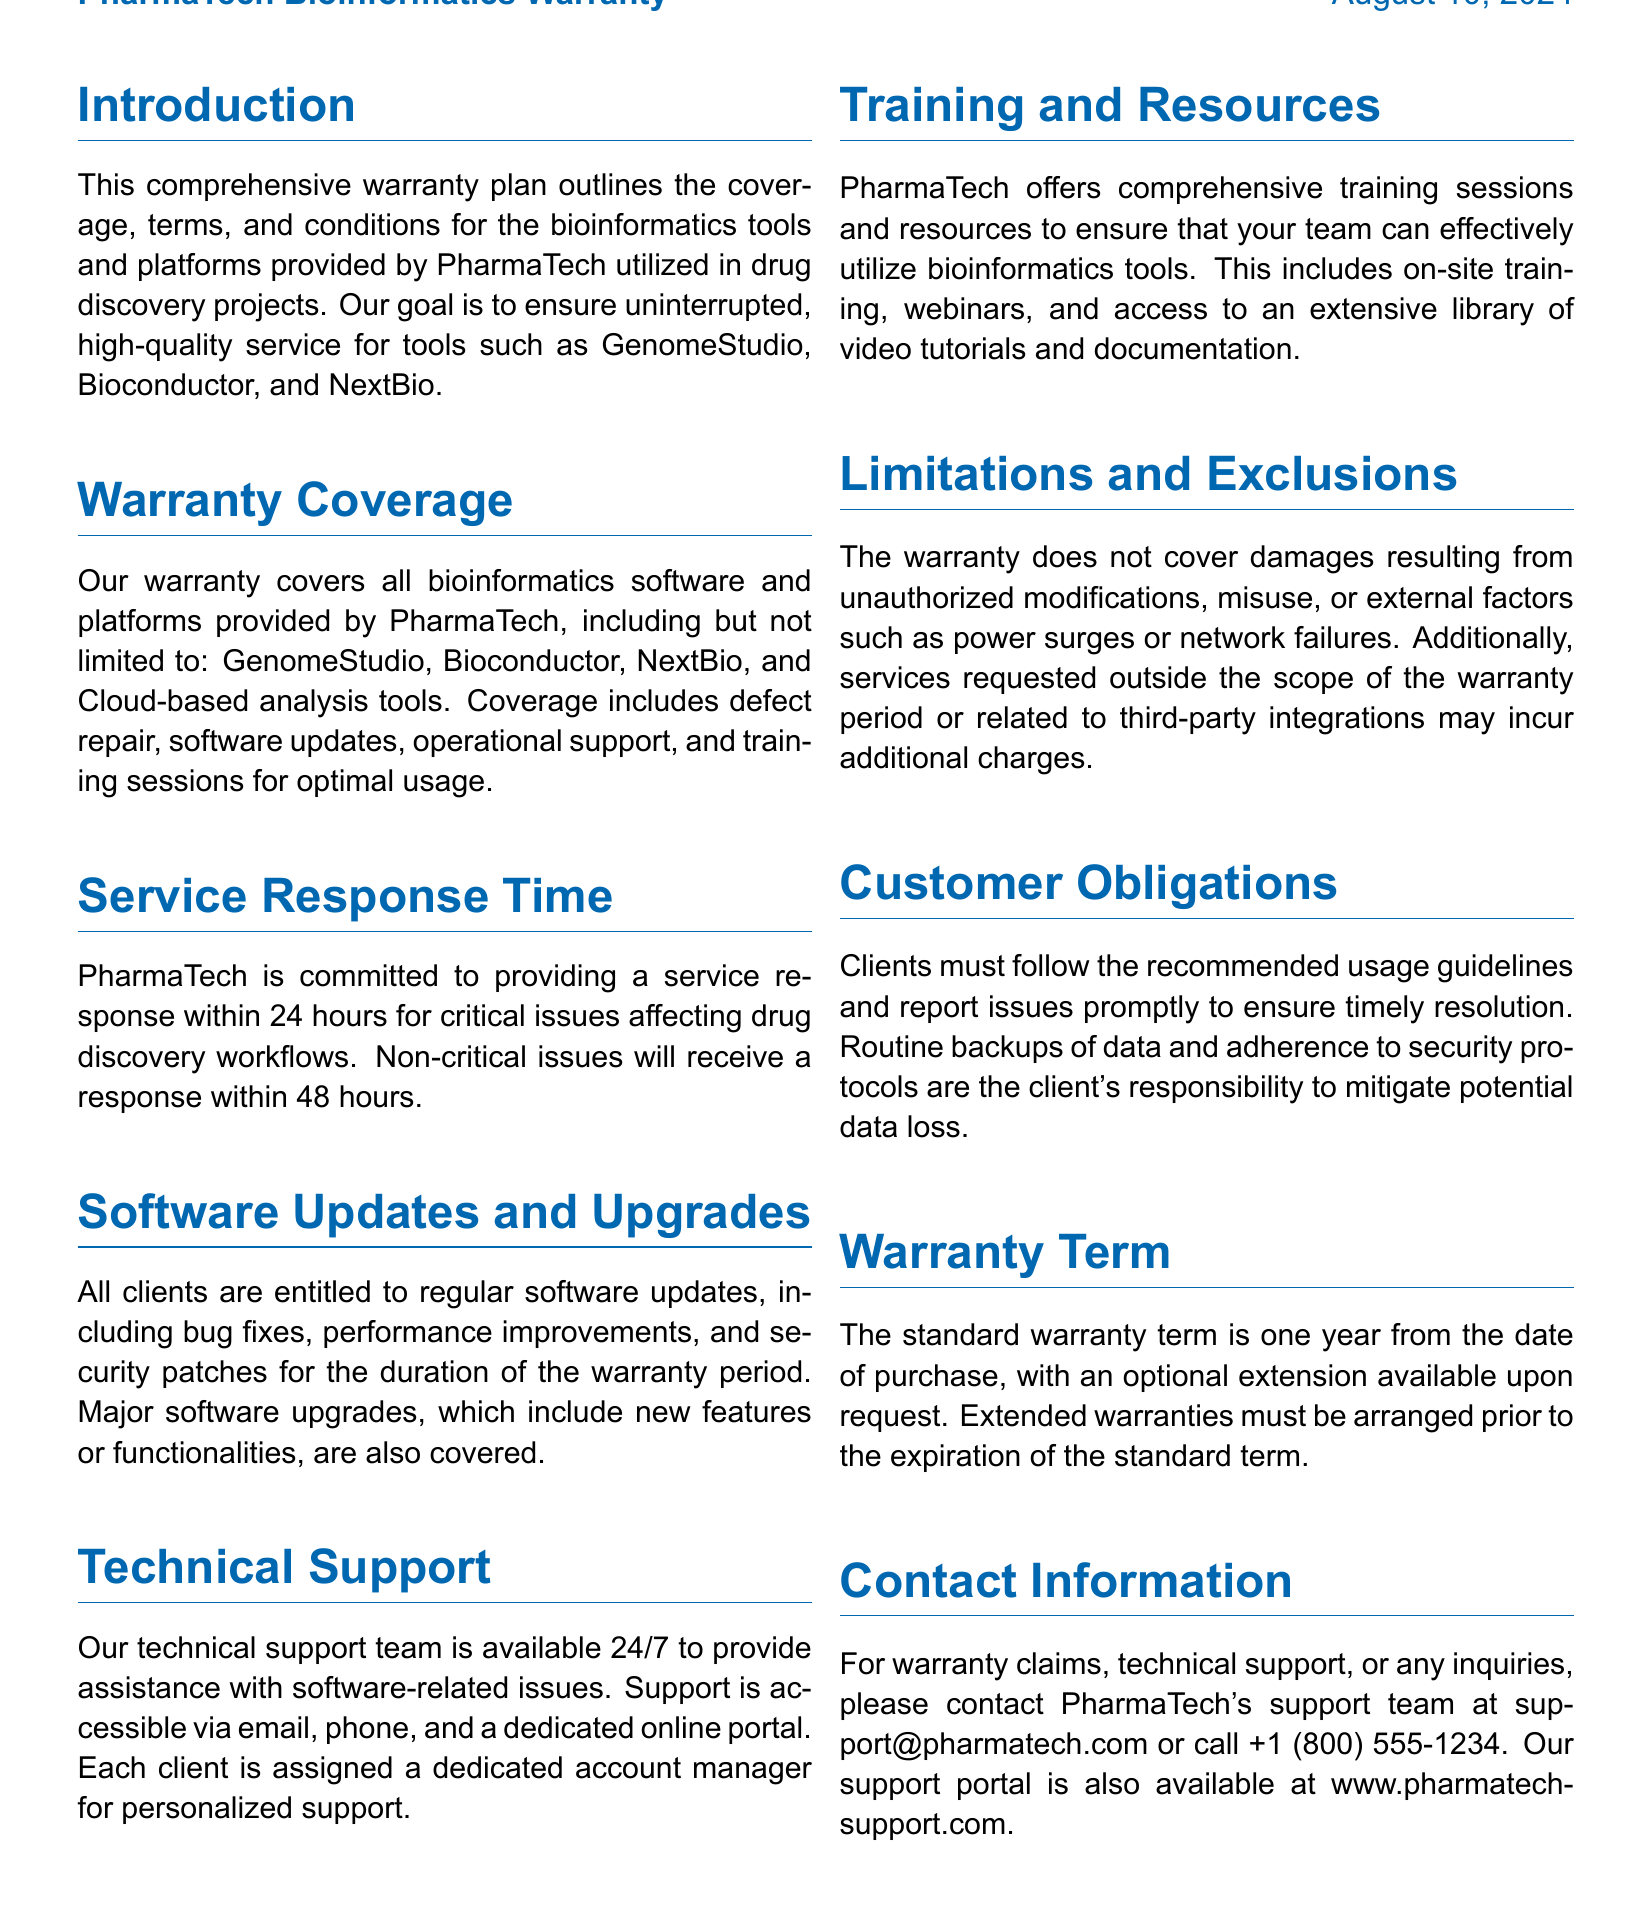What is the warranty term? The standard warranty term is specified in the document and is one year from the date of purchase.
Answer: one year What coverage does the warranty provide? The document lists specific areas covered by the warranty, including defect repair, software updates, and operational support.
Answer: defect repair, software updates, operational support How long is the service response for critical issues? The document states the commitment for service response times regarding critical issues affecting drug discovery workflows.
Answer: 24 hours Which platforms are included in the warranty? The document mentions specific bioinformatics software that falls under the warranty.
Answer: GenomeStudio, Bioconductor, NextBio, Cloud-based analysis tools What additional training resources are provided? The document outlines the types of training and resources offered to clients under the warranty.
Answer: on-site training, webinars, video tutorials, documentation What obligations do clients have? The document specifies client obligations regarding usage guidelines and issue reporting.
Answer: follow guidelines, report issues promptly What is the contact email for warranty claims? The document provides specific contact information for warranty claims and inquiries.
Answer: support@pharmatech.com What factors are excluded from the warranty coverage? The document details specific situations which are not covered by the warranty.
Answer: unauthorized modifications, misuse, external factors What type of support is offered by PharmaTech? The document describes the availability of technical support and means of access.
Answer: 24/7 technical support 